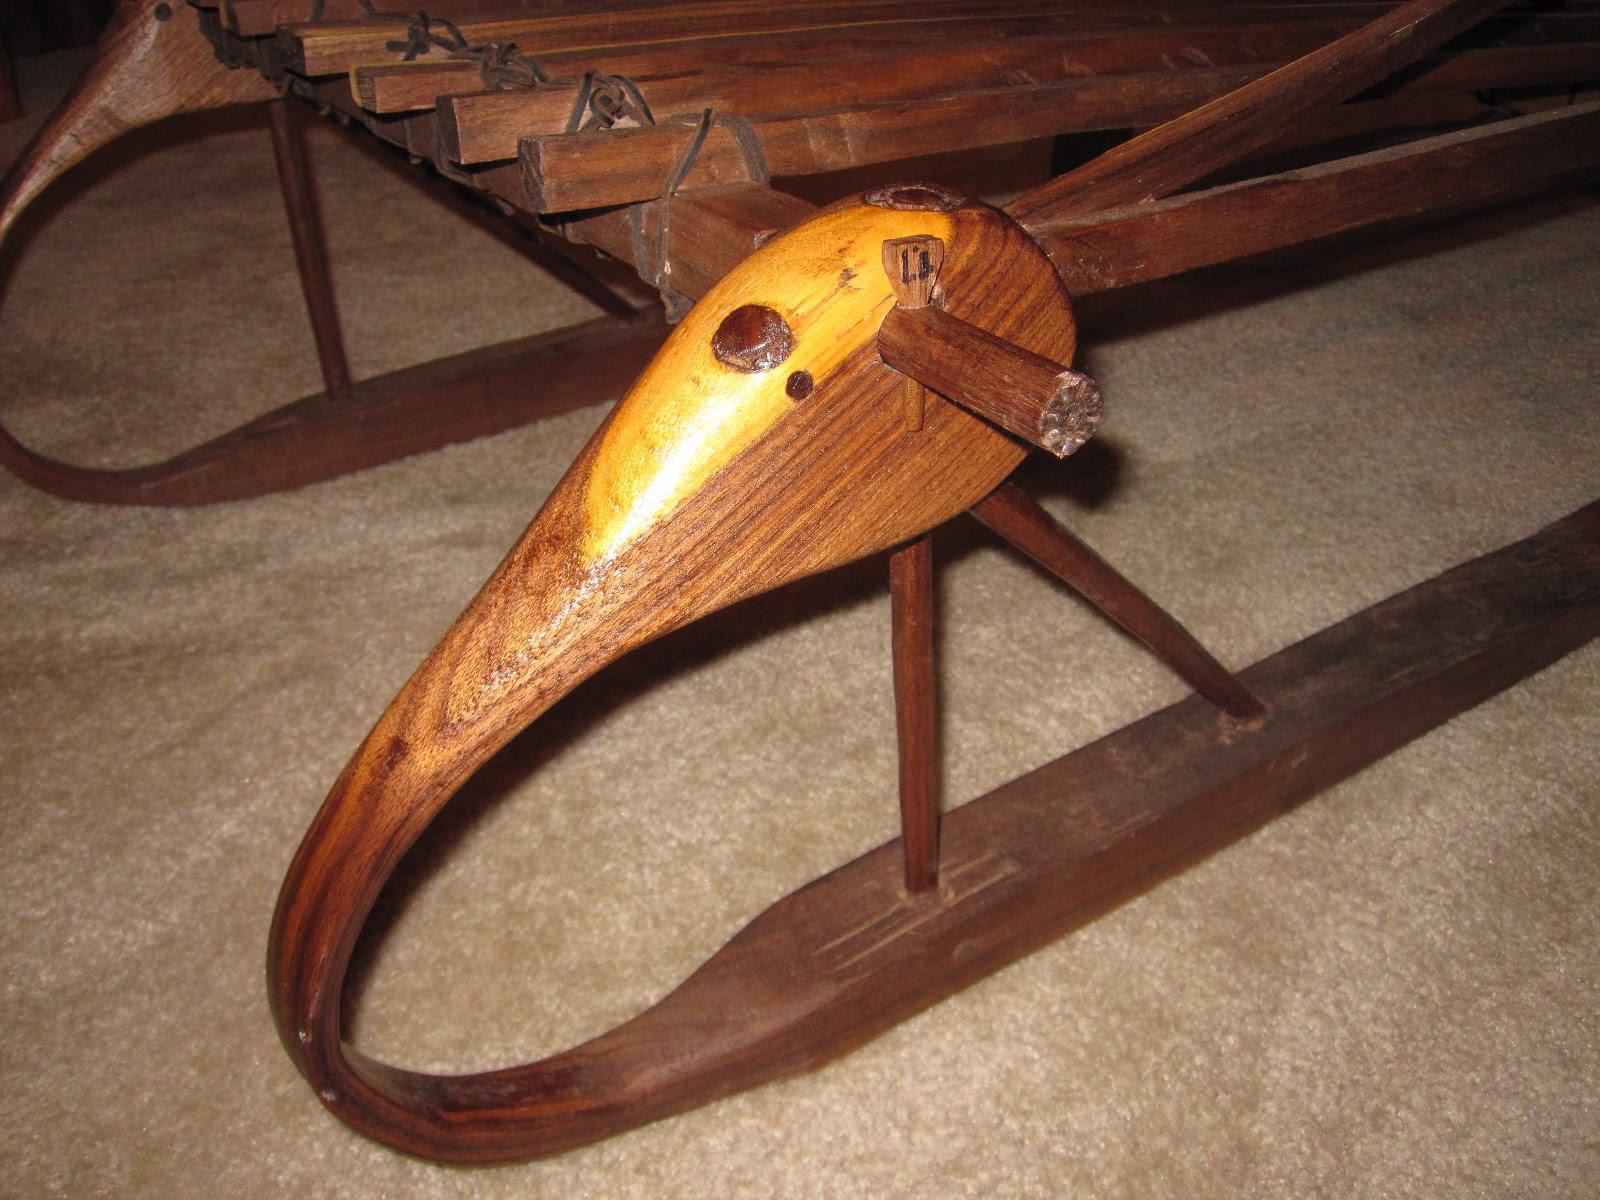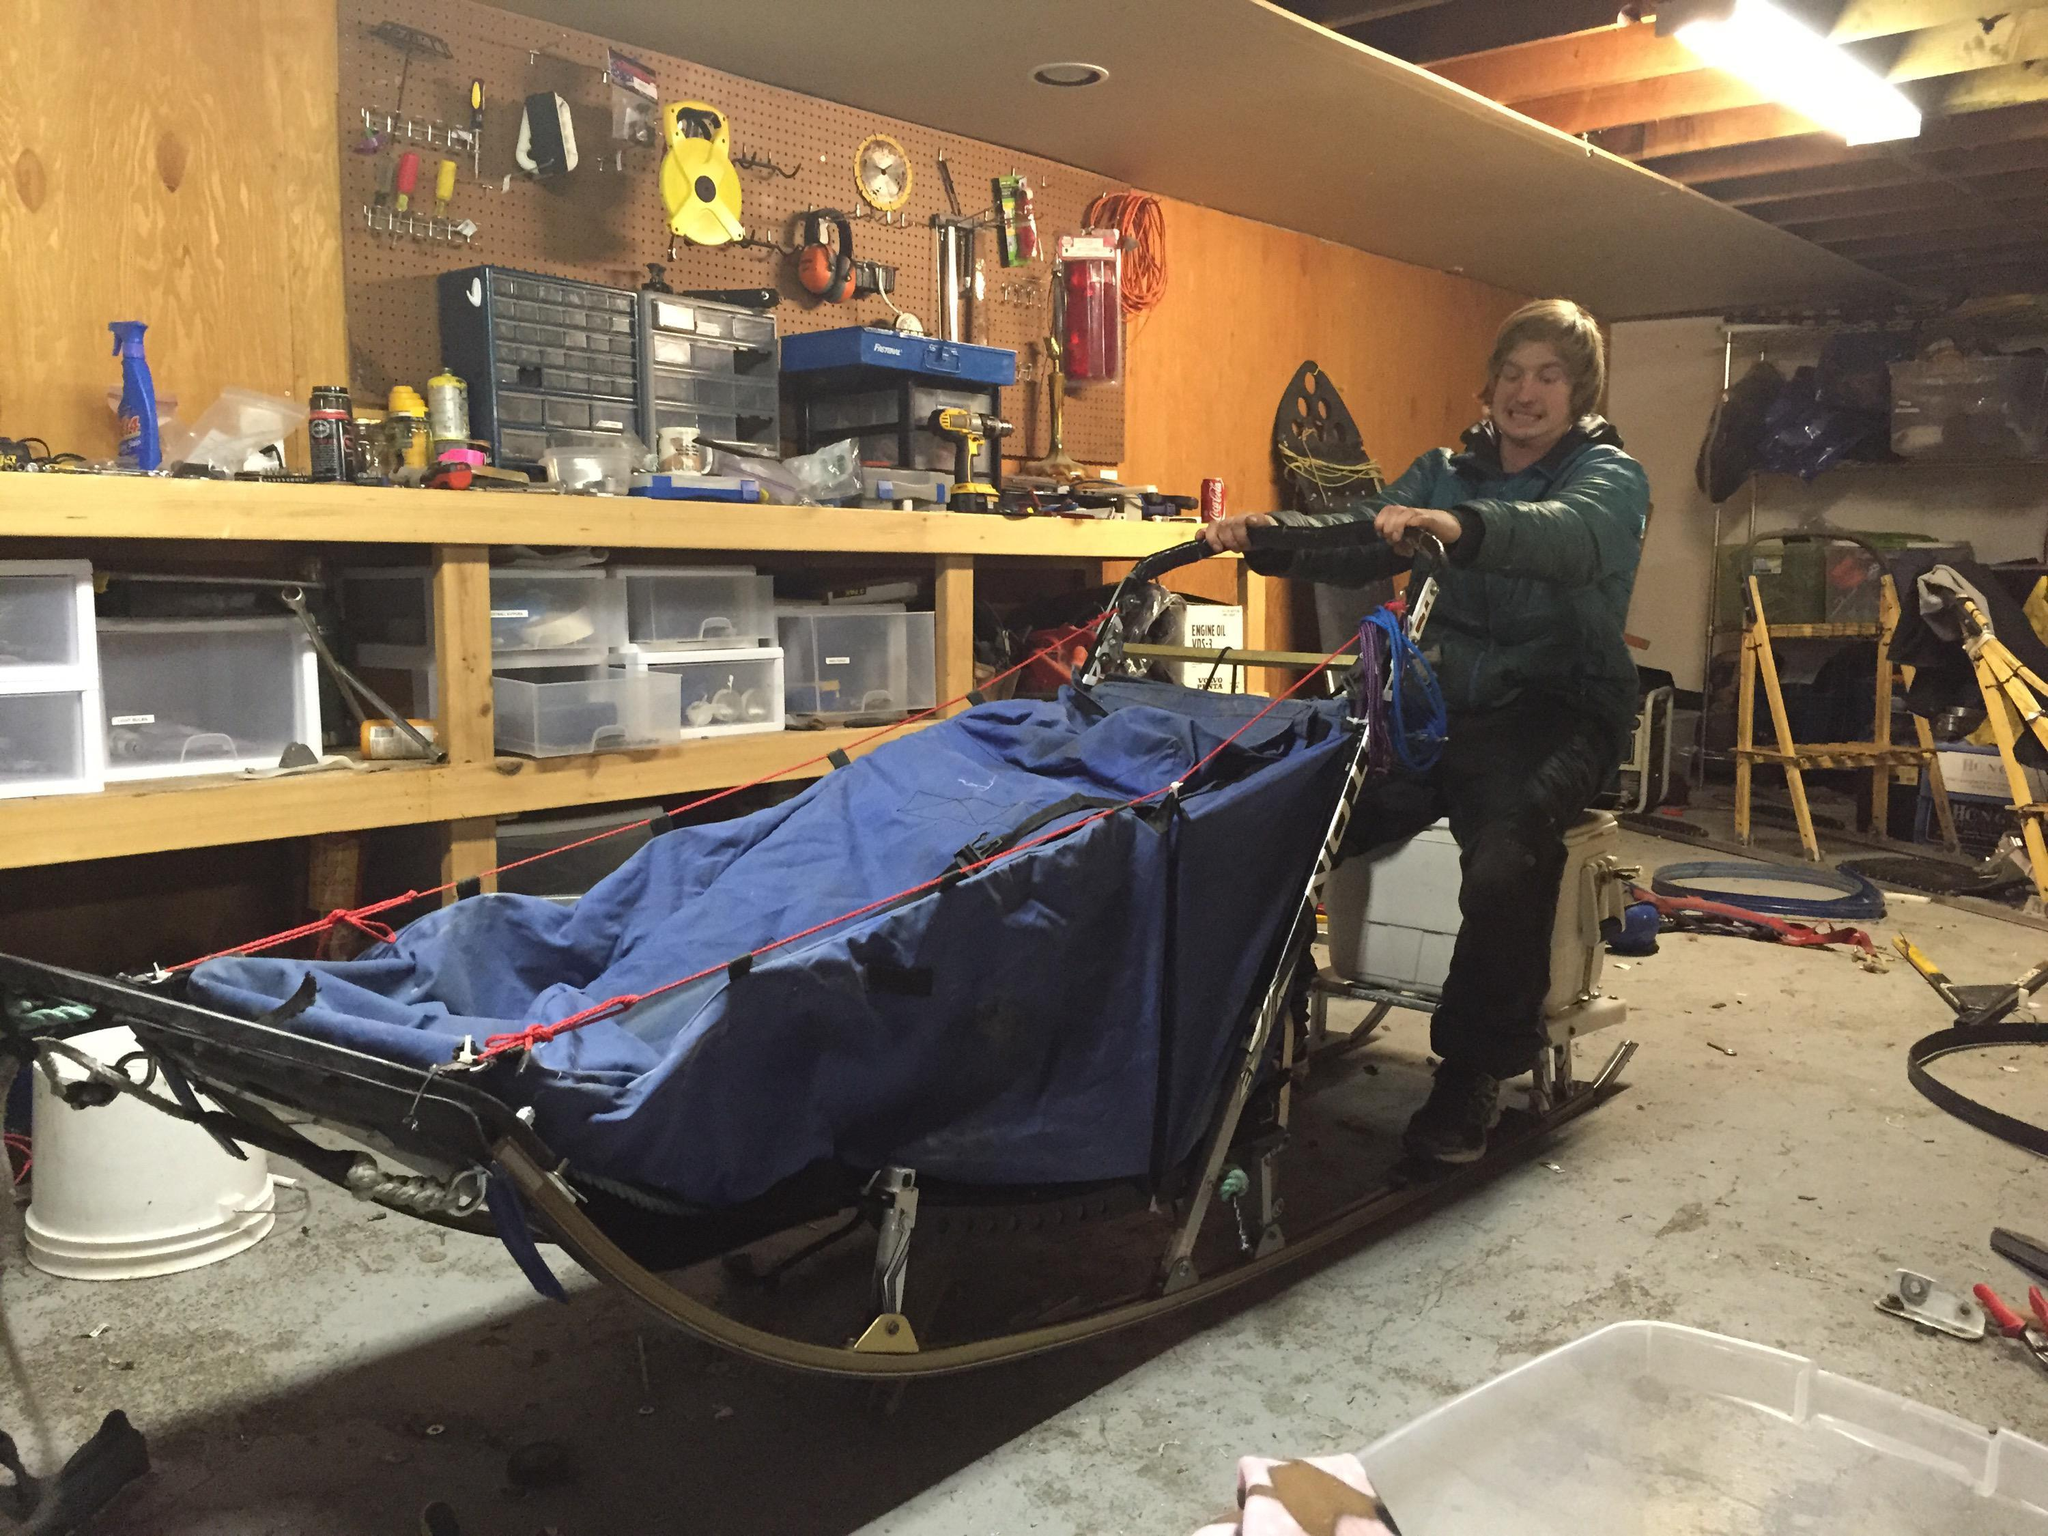The first image is the image on the left, the second image is the image on the right. Evaluate the accuracy of this statement regarding the images: "There are two pairs of downhill skis.". Is it true? Answer yes or no. No. The first image is the image on the left, the second image is the image on the right. Examine the images to the left and right. Is the description "There is at least one person pictured with a sled like object." accurate? Answer yes or no. Yes. 